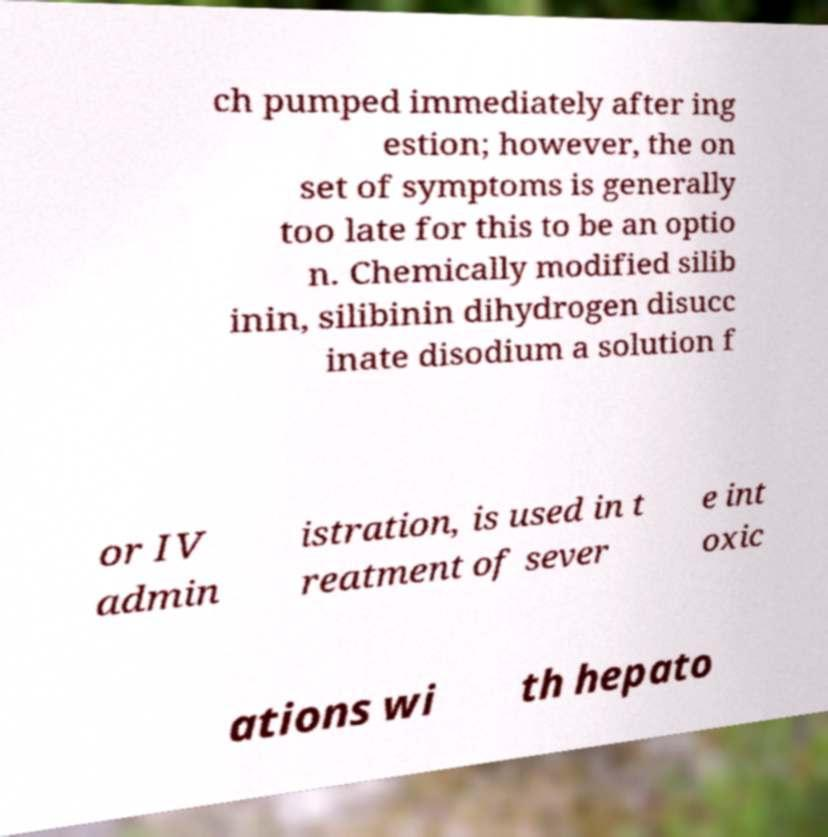Can you accurately transcribe the text from the provided image for me? ch pumped immediately after ing estion; however, the on set of symptoms is generally too late for this to be an optio n. Chemically modified silib inin, silibinin dihydrogen disucc inate disodium a solution f or IV admin istration, is used in t reatment of sever e int oxic ations wi th hepato 